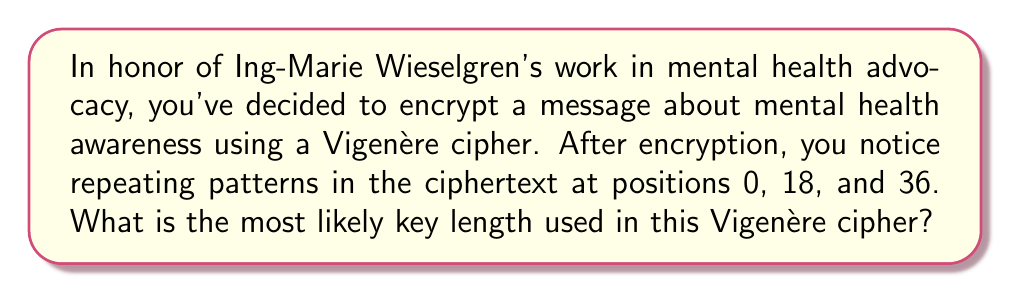Provide a solution to this math problem. To determine the most likely key length in a Vigenère cipher given ciphertext patterns, we follow these steps:

1. Identify the distances between repeating patterns:
   - Distance between 0 and 18: 18 - 0 = 18
   - Distance between 18 and 36: 36 - 18 = 18

2. Calculate the greatest common divisor (GCD) of these distances:
   $GCD(18, 18) = 18$

3. The GCD represents the most likely key length because:
   - In a Vigenère cipher, patterns repeat when the same part of the key aligns with similar plaintext.
   - The key length must be a factor of the distances between repeating patterns.
   - The largest such factor (the GCD) is the most probable key length.

4. Verify that 18 is a factor of all observed distances:
   18 divides 18 (18 ÷ 18 = 1)
   18 divides 36 (36 ÷ 18 = 2)

Therefore, the most likely key length is 18 characters.
Answer: 18 